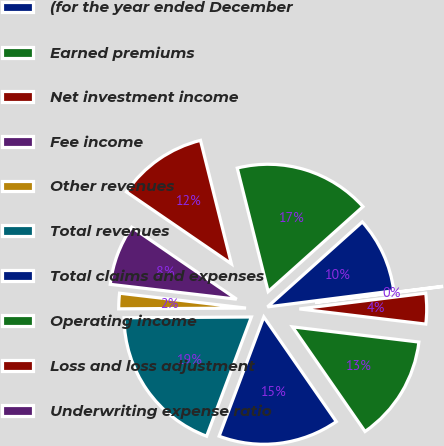Convert chart. <chart><loc_0><loc_0><loc_500><loc_500><pie_chart><fcel>(for the year ended December<fcel>Earned premiums<fcel>Net investment income<fcel>Fee income<fcel>Other revenues<fcel>Total revenues<fcel>Total claims and expenses<fcel>Operating income<fcel>Loss and loss adjustment<fcel>Underwriting expense ratio<nl><fcel>9.62%<fcel>17.28%<fcel>11.53%<fcel>7.7%<fcel>1.96%<fcel>19.19%<fcel>15.36%<fcel>13.45%<fcel>3.87%<fcel>0.04%<nl></chart> 